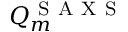<formula> <loc_0><loc_0><loc_500><loc_500>Q _ { m } ^ { S A X S }</formula> 